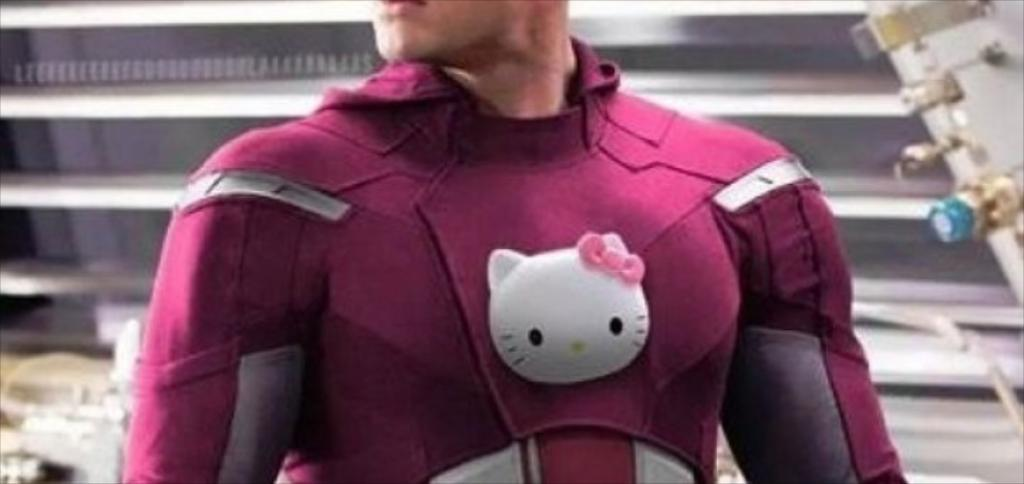What is present in the image? There is a person in the image. What is the person wearing? The person is wearing a red dress. What memory does the person in the image have about the doll they discovered? There is no doll or memory mentioned in the image, so it is not possible to answer that question. 